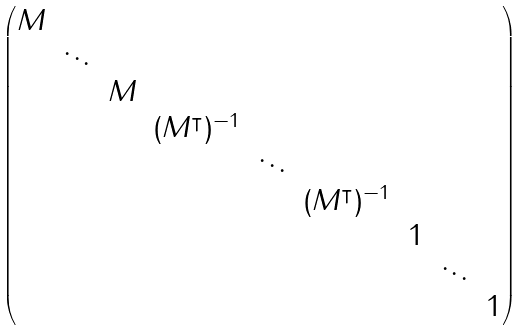Convert formula to latex. <formula><loc_0><loc_0><loc_500><loc_500>\begin{pmatrix} M & & & & & & & \\ & \ddots & & & & & & \\ & & M & & & & & \\ & & & ( M ^ { \intercal } ) ^ { - 1 } & & & & \\ & & & & \ddots & & & \\ & & & & & ( M ^ { \intercal } ) ^ { - 1 } & & \\ & & & & & & 1 & \\ & & & & & & & \ddots & \\ & & & & & & & & 1 \\ \end{pmatrix}</formula> 